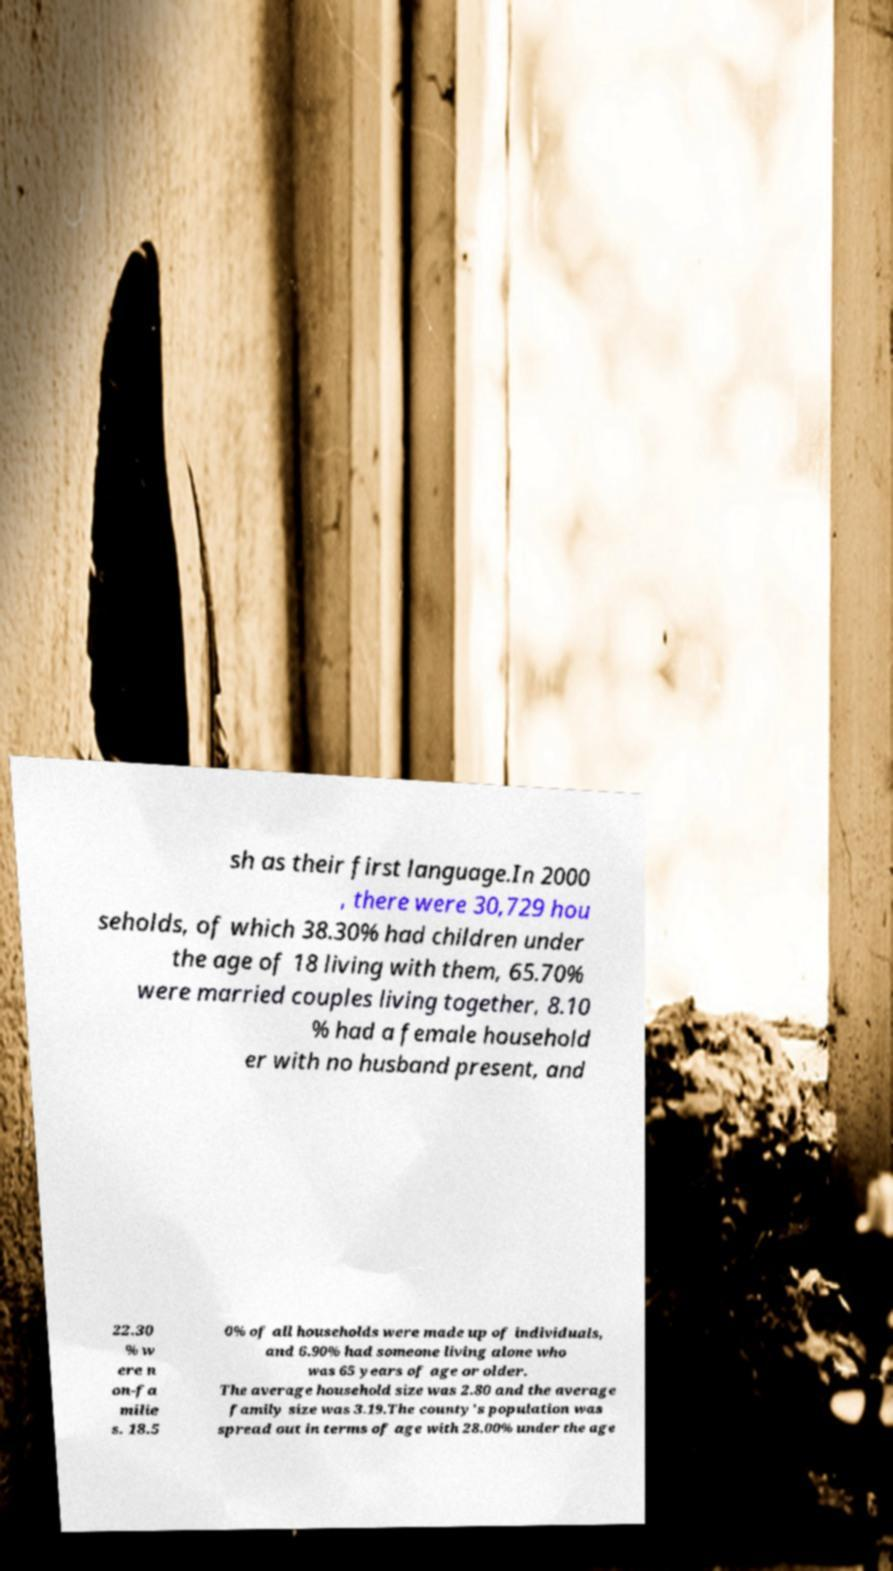Could you extract and type out the text from this image? sh as their first language.In 2000 , there were 30,729 hou seholds, of which 38.30% had children under the age of 18 living with them, 65.70% were married couples living together, 8.10 % had a female household er with no husband present, and 22.30 % w ere n on-fa milie s. 18.5 0% of all households were made up of individuals, and 6.90% had someone living alone who was 65 years of age or older. The average household size was 2.80 and the average family size was 3.19.The county's population was spread out in terms of age with 28.00% under the age 